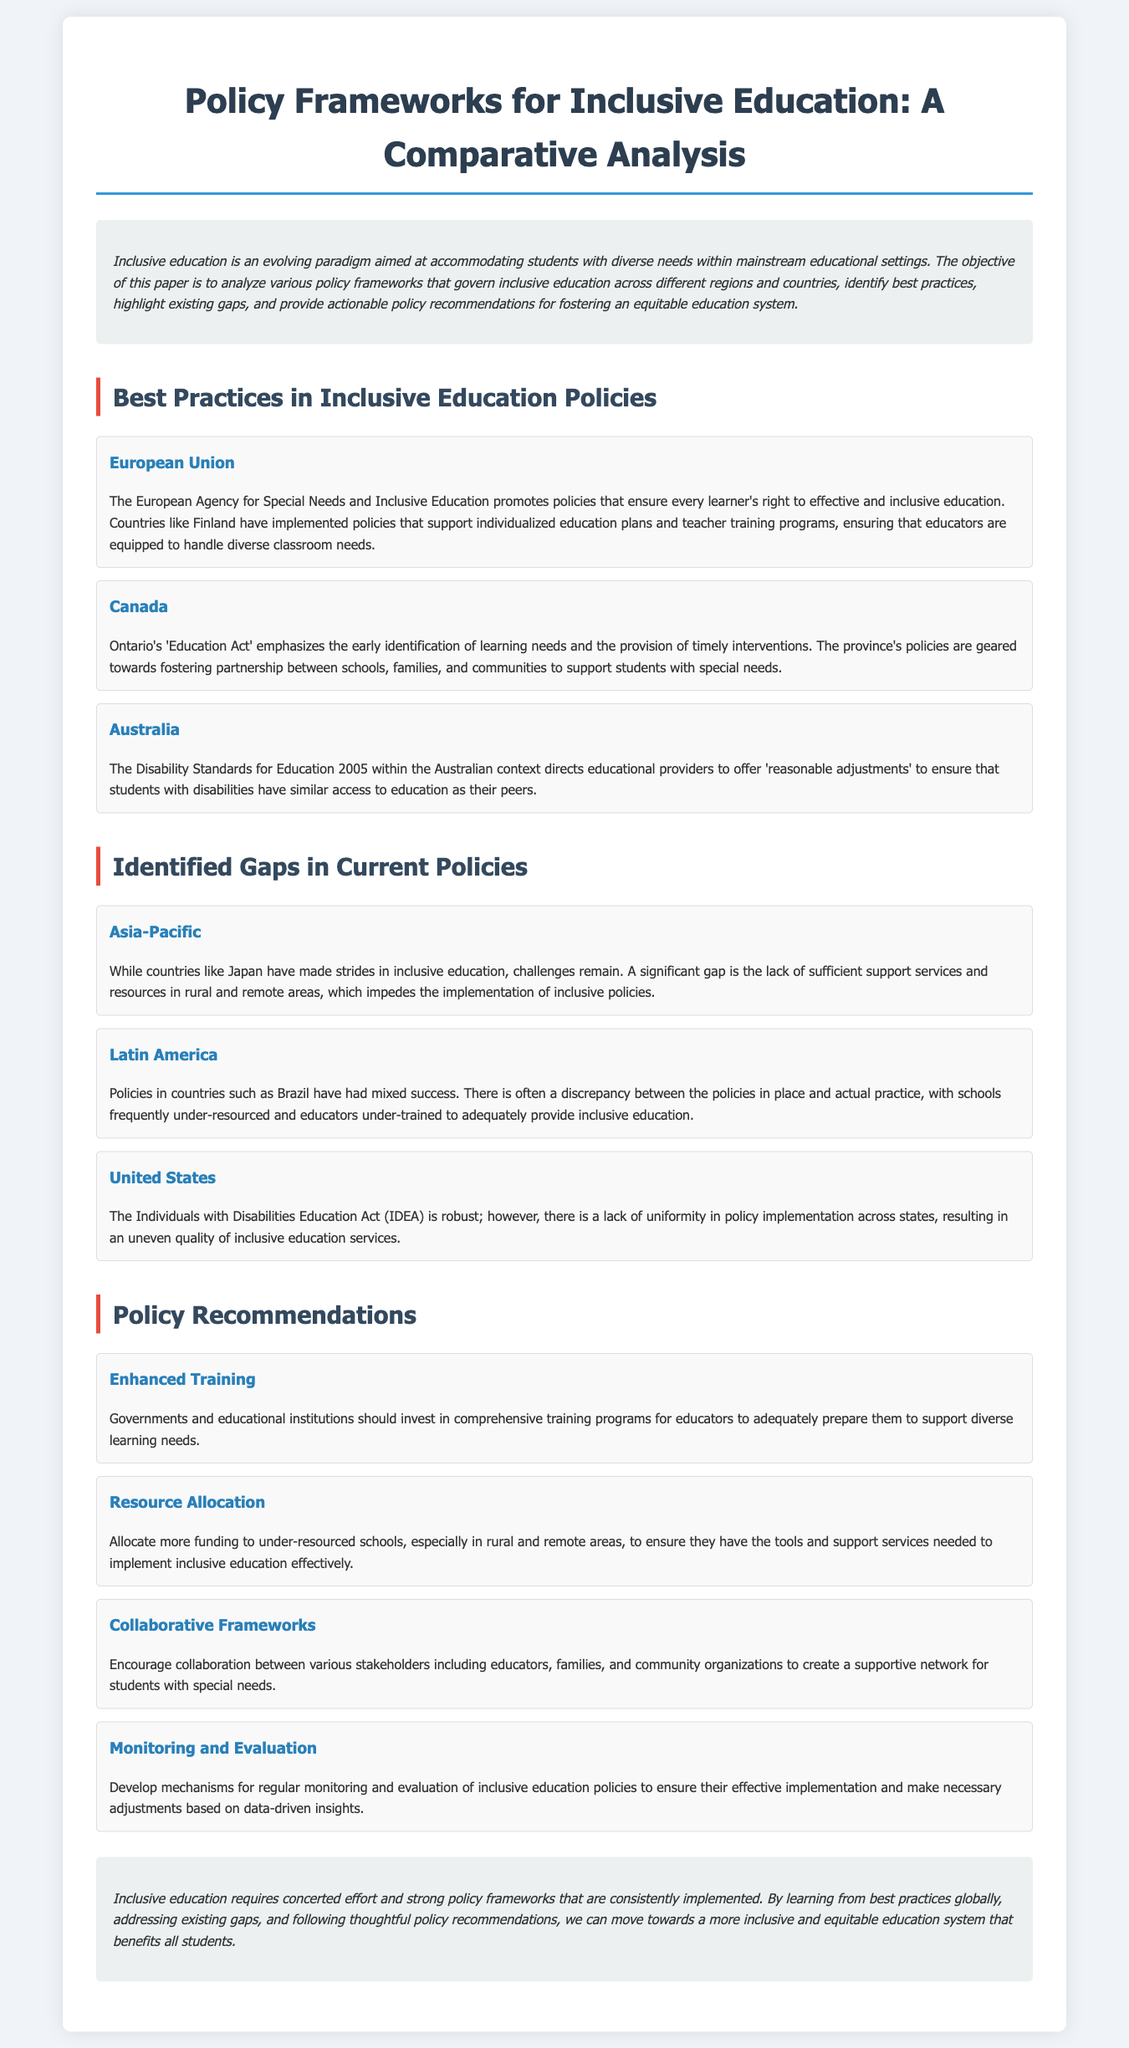What is the title of the whitepaper? The title of the whitepaper is located at the top of the document.
Answer: Policy Frameworks for Inclusive Education: A Comparative Analysis Which country is mentioned for best practices in the European Union? The best practices section lists Finland as an example from the European Union.
Answer: Finland What act does Ontario emphasize for inclusive education? The document cites Ontario's 'Education Act' in relation to best practices in Canada.
Answer: Education Act What is a significant gap identified in the Asia-Pacific region? The document states the gap is the lack of sufficient support services and resources in rural areas.
Answer: Lack of sufficient support services What percentage of funding should be allocated to under-resourced schools? The document does not specify a percentage of funding but emphasizes the need for more funding.
Answer: More funding What type of frameworks should be encouraged according to policy recommendations? The recommendations suggest encouraging collaborative frameworks among stakeholders.
Answer: Collaborative frameworks What year were the Disability Standards for Education established in Australia? The document mentions the Disability Standards for Education were established in 2005.
Answer: 2005 Which policy framework provides guidelines for regular monitoring? The policy recommendations section includes monitoring and evaluation mechanisms.
Answer: Monitoring and evaluation What is the primary aim of inclusive education as stated in the introduction? The introduction specifies that the primary aim is to accommodate students with diverse needs.
Answer: Accommodating students with diverse needs 